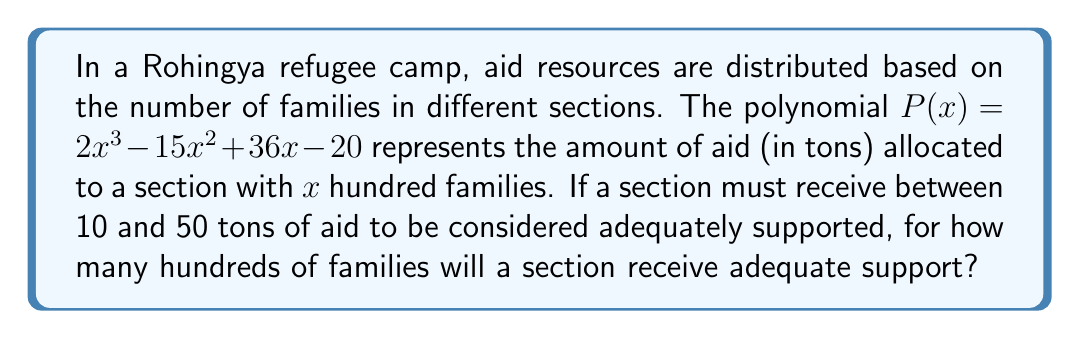Can you solve this math problem? To solve this problem, we need to find the range of $x$ values that satisfy the inequality:

$$10 \leq 2x^3 - 15x^2 + 36x - 20 \leq 50$$

Let's solve this step-by-step:

1) First, we'll solve the left inequality:
   $$2x^3 - 15x^2 + 36x - 20 \geq 10$$
   $$2x^3 - 15x^2 + 36x - 30 \geq 0$$

2) Now, the right inequality:
   $$2x^3 - 15x^2 + 36x - 20 \leq 50$$
   $$2x^3 - 15x^2 + 36x - 70 \leq 0$$

3) We can factor the left inequality:
   $$(x - 1)(2x^2 - 13x + 30) \geq 0$$
   $$(x - 1)(2x - 10)(x - 3) \geq 0$$

4) The right inequality factors as:
   $$(x - 1)(2x^2 - 13x + 35) \leq 0$$
   $$(x - 1)(2x - 7)(x - 5) \leq 0$$

5) Combining these inequalities and solving:
   - $x \geq 1$ and $x \leq 3.5$ (from left inequality)
   - $x \geq 1$ and $x \leq 5$ (from right inequality)

6) The overlapping solution is:
   $$1 \leq x \leq 3.5$$

7) Since $x$ represents hundreds of families, we need to round down to the nearest whole number for the upper bound.

Therefore, sections with 100 to 300 families (1 to 3 hundred families) will receive adequate support.
Answer: 3 